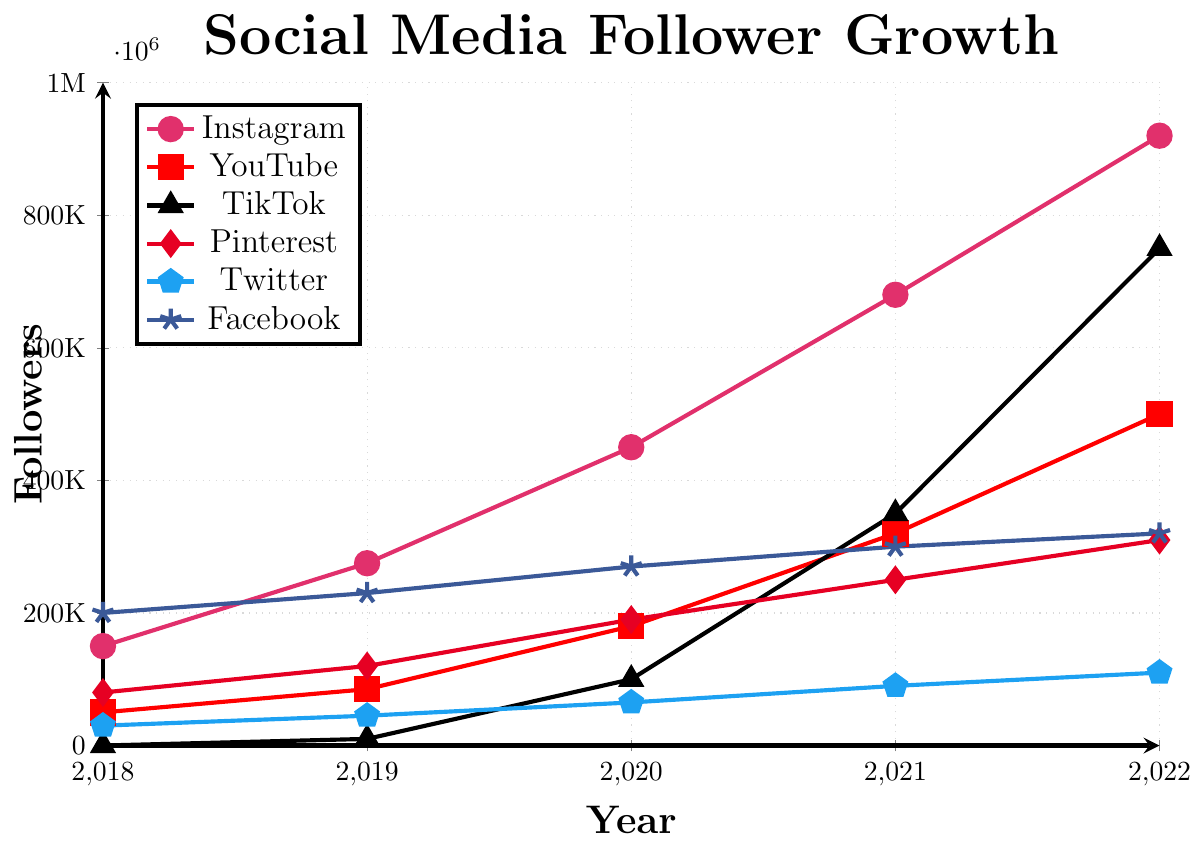What's the total follower count for Instagram and TikTok in 2022? To find the total number of followers for Instagram and TikTok in 2022, we add their followers: Instagram has 920,000 followers and TikTok has 750,000 followers. So, the total is 920,000 + 750,000 = 1,670,000
Answer: 1,670,000 Which platform had the highest growth rate between 2019 and 2022? To determine which platform had the highest growth rate between 2019 and 2022, we need to compare the increase in followers across platforms. Instagram: 920,000 - 275,000 = 645,000, YouTube: 500,000 - 85,000 = 415,000, TikTok: 750,000 - 10,000 = 740,000, Pinterest: 310,000 - 120,000 = 190,000, Twitter: 110,000 - 45,000 = 65,000, Facebook: 320,000 - 230,000 = 90,000. TikTok had the highest increase of 740,000
Answer: TikTok Which platform started with zero followers in 2018 but gained a significant amount by 2022? By looking at the figure, TikTok had zero followers in 2018 and reached 750,000 followers by 2022.
Answer: TikTok What was the difference in follower count between Facebook and Twitter in 2022? Facebook had 320,000 followers and Twitter had 110,000 followers in 2022. The difference is 320,000 - 110,000 = 210,000
Answer: 210,000 Which platform had the smallest increase in followers from 2018 to 2022? To determine the smallest growth in followers from 2018 to 2022, we calculate the difference for each platform: Instagram: 920,000 - 150,000 = 770,000, YouTube: 500,000 - 50,000 = 450,000, TikTok: 750,000 - 0 = 750,000, Pinterest: 310,000 - 80,000 = 230,000, Twitter: 110,000 - 30,000 = 80,000, Facebook: 320,000 - 200,000 = 120,000. Twitter had the smallest increase of 80,000
Answer: Twitter How many platforms had at least 500,000 followers by 2022? By examining the 2022 follower counts for each platform, we see that Instagram (920,000), YouTube (500,000), and TikTok (750,000) each had at least 500,000 followers. There are 3 platforms in total.
Answer: 3 Among Instagram, YouTube, and Facebook, which platform had the most followers in 2020? In 2020, Instagram had 450,000 followers, YouTube had 180,000 followers, and Facebook had 270,000 followers. Instagram had the most followers among these platforms.
Answer: Instagram 